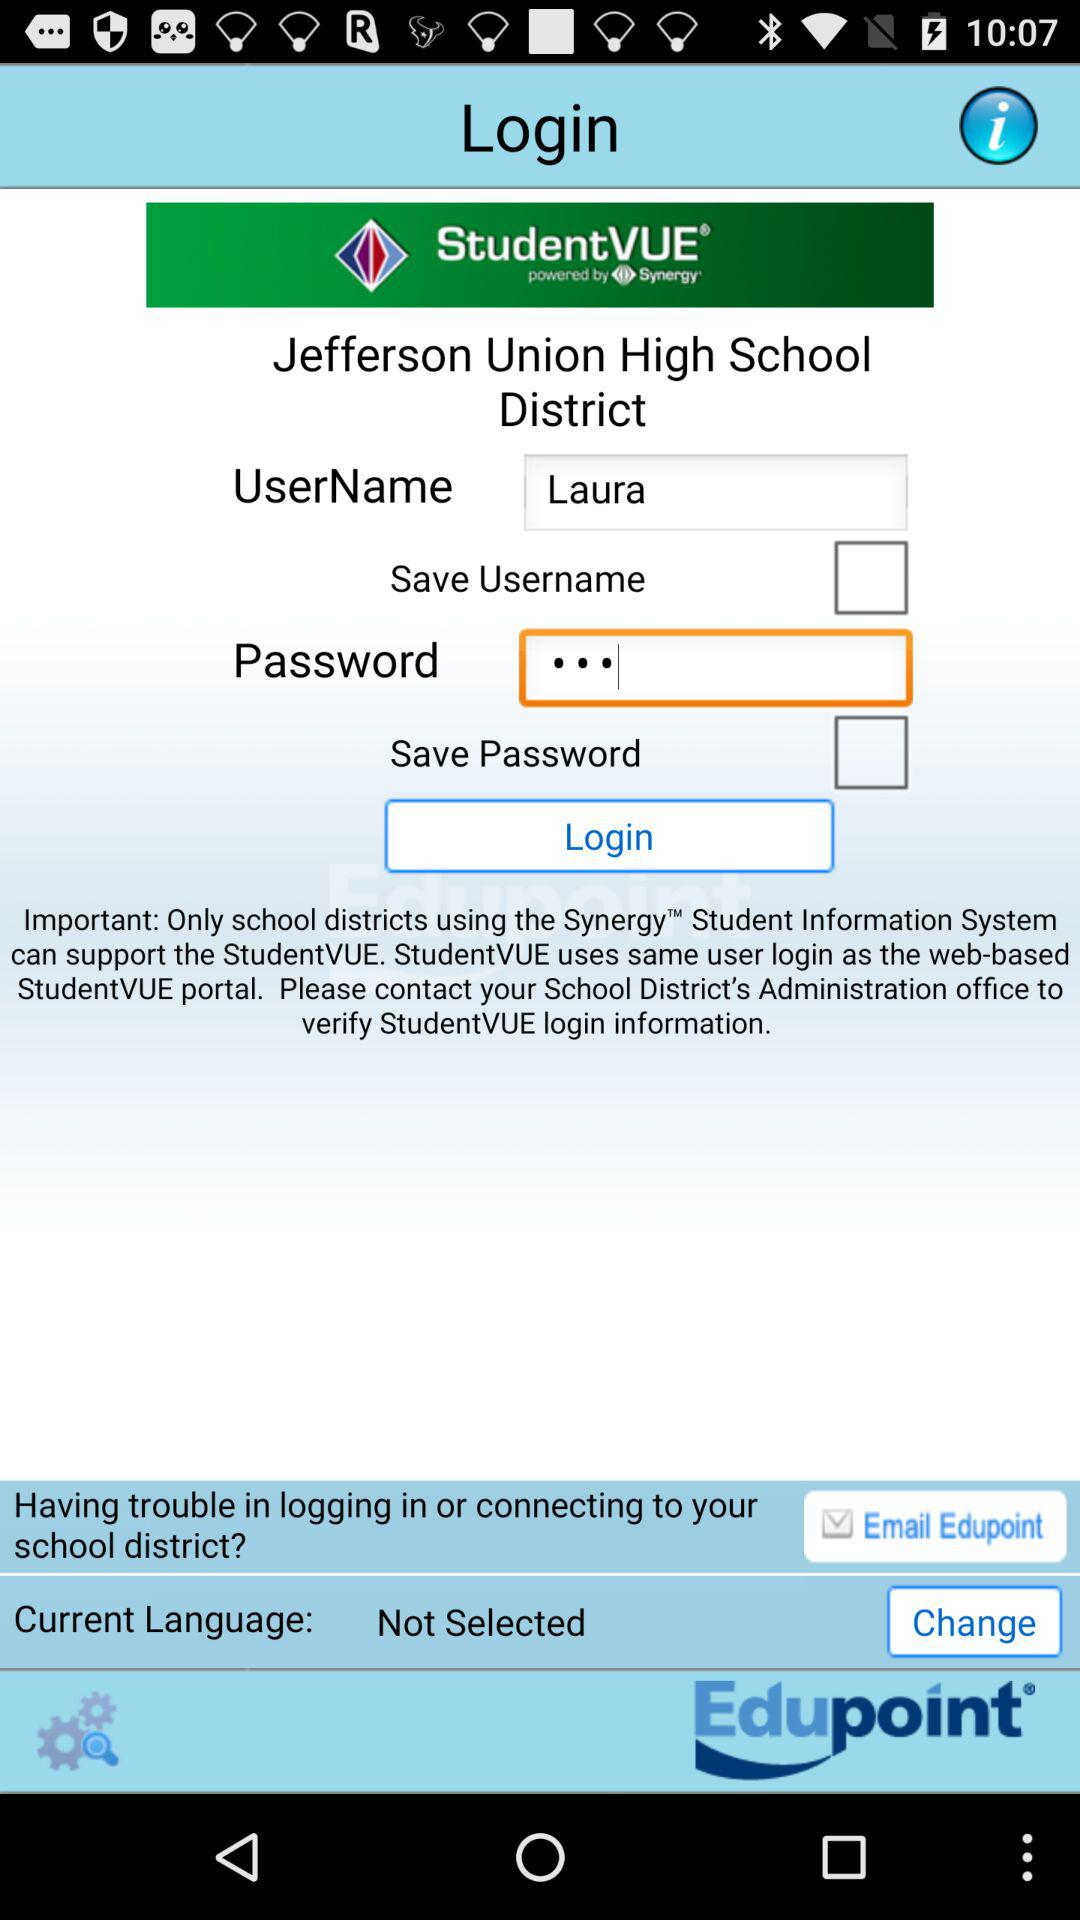What is the name of the school? The name of the school is "Jefferson Union High School District". 